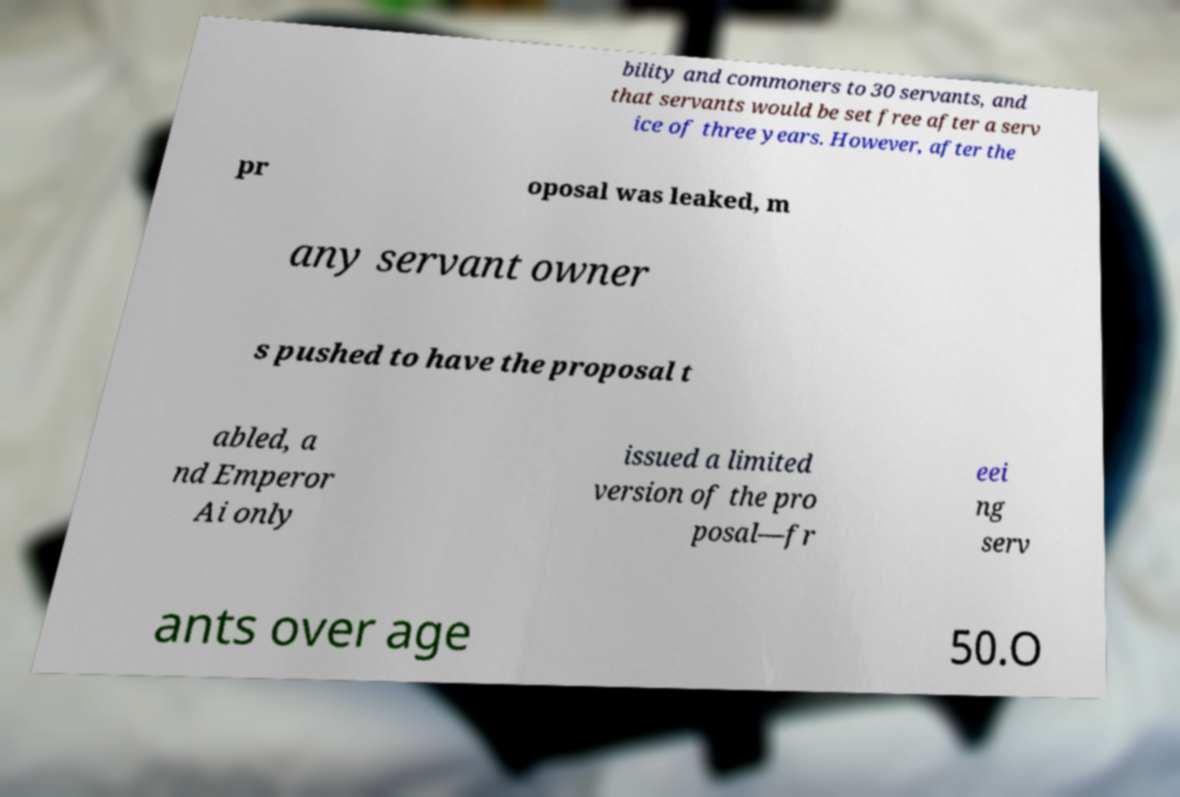Can you read and provide the text displayed in the image?This photo seems to have some interesting text. Can you extract and type it out for me? bility and commoners to 30 servants, and that servants would be set free after a serv ice of three years. However, after the pr oposal was leaked, m any servant owner s pushed to have the proposal t abled, a nd Emperor Ai only issued a limited version of the pro posal—fr eei ng serv ants over age 50.O 